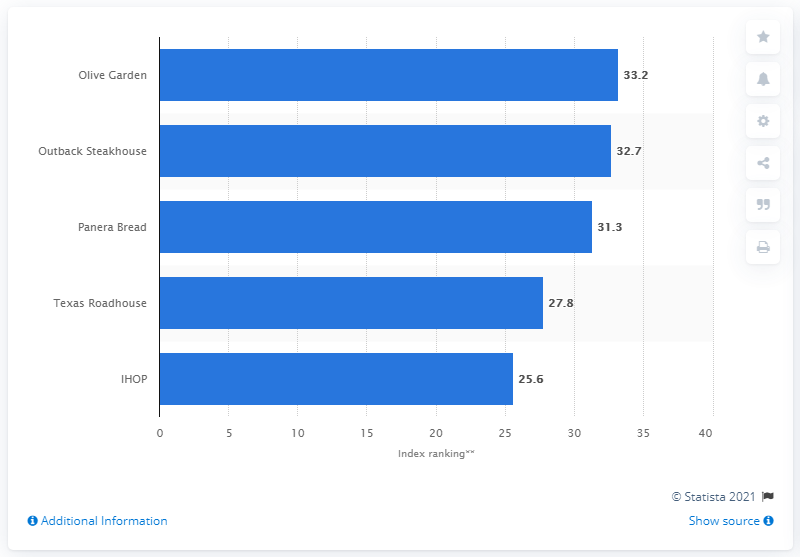Identify some key points in this picture. According to YouGov's brand index in 2018, Outback Steakhouse was ranked 32.7 out of 100. Outback Steakhouse received a score of 32.7 out of 100, indicating a below average performance. According to the given data, Olive Garden ranked highest with a score of 33.2. 